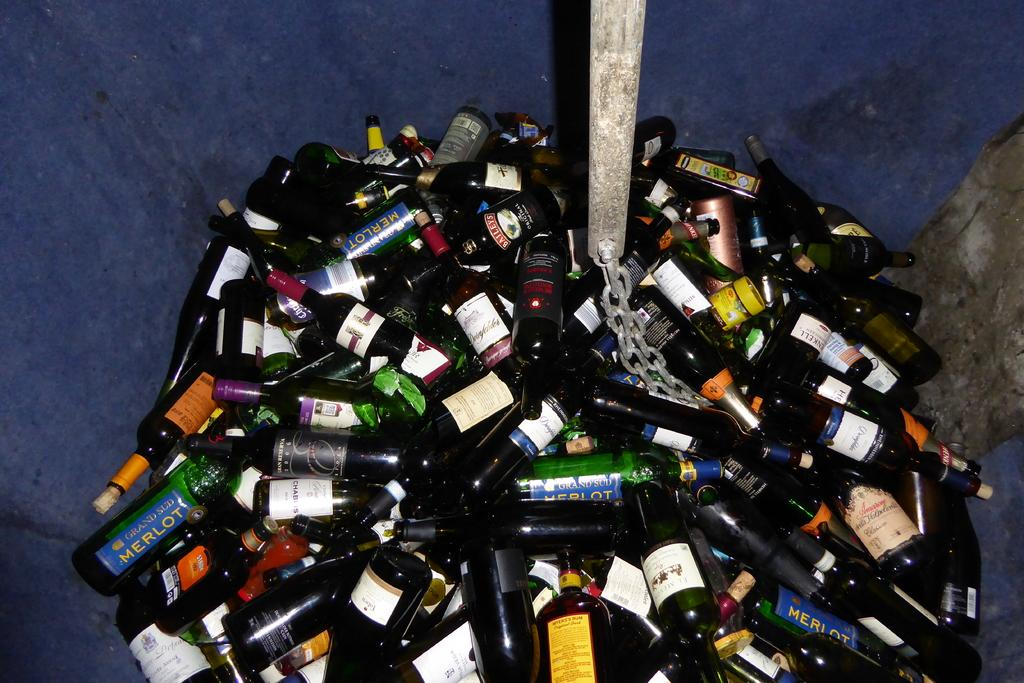<image>
Offer a succinct explanation of the picture presented. A whole bunch of bottles are randomly piled on top of each other, including wine bottles of Merlot. 